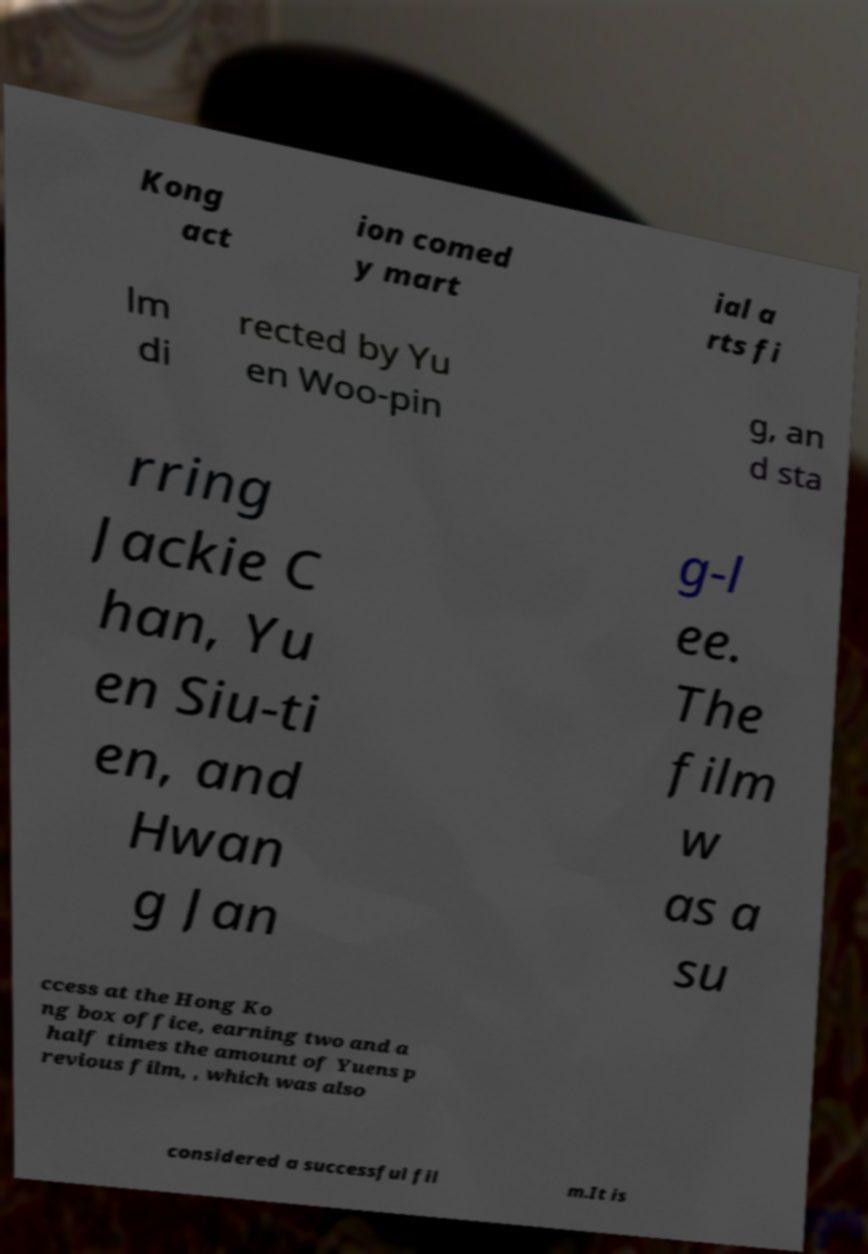Can you read and provide the text displayed in the image?This photo seems to have some interesting text. Can you extract and type it out for me? Kong act ion comed y mart ial a rts fi lm di rected by Yu en Woo-pin g, an d sta rring Jackie C han, Yu en Siu-ti en, and Hwan g Jan g-l ee. The film w as a su ccess at the Hong Ko ng box office, earning two and a half times the amount of Yuens p revious film, , which was also considered a successful fil m.It is 